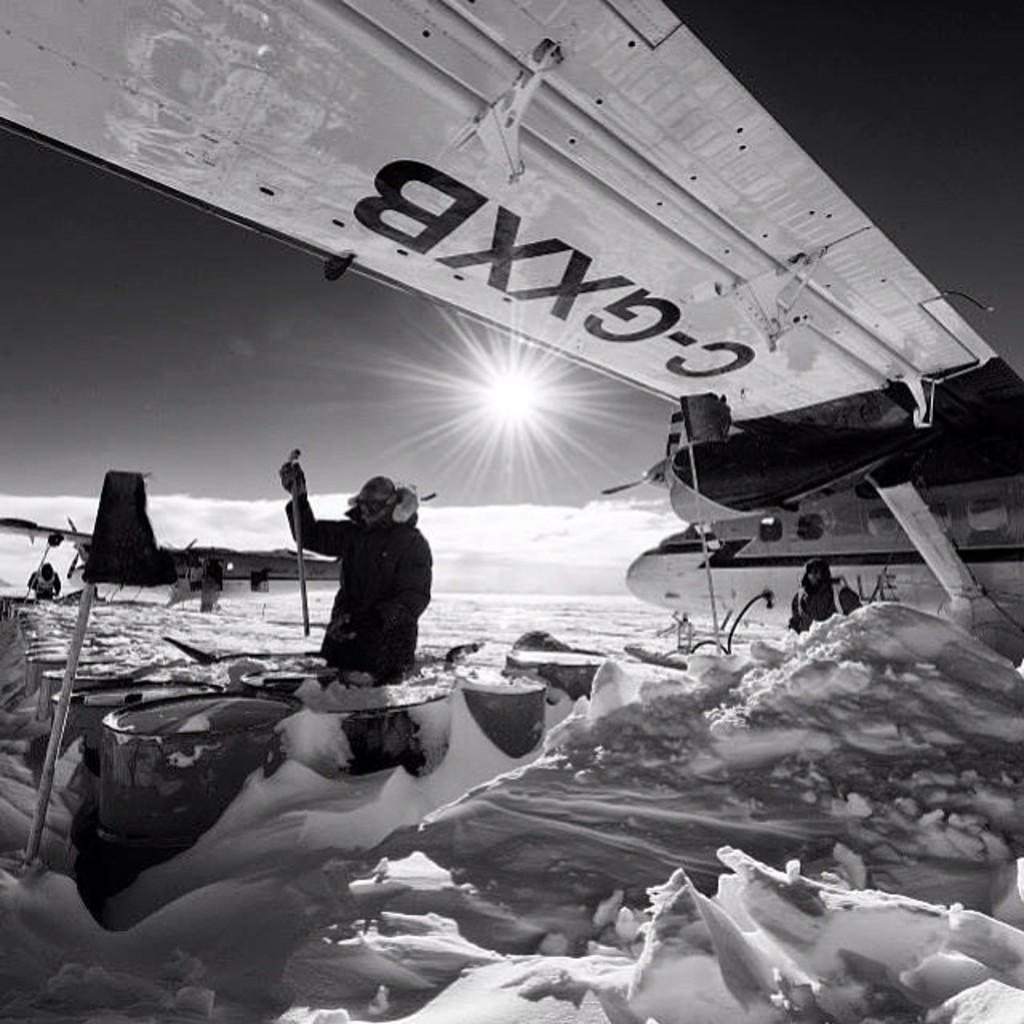Provide a one-sentence caption for the provided image. a man sitting underneath a airplane wing with the letters c-gxxb on it. 